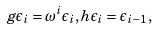Convert formula to latex. <formula><loc_0><loc_0><loc_500><loc_500>g \epsilon _ { i } = \omega ^ { i } \epsilon _ { i } , h \epsilon _ { i } = \epsilon _ { i - 1 } ,</formula> 